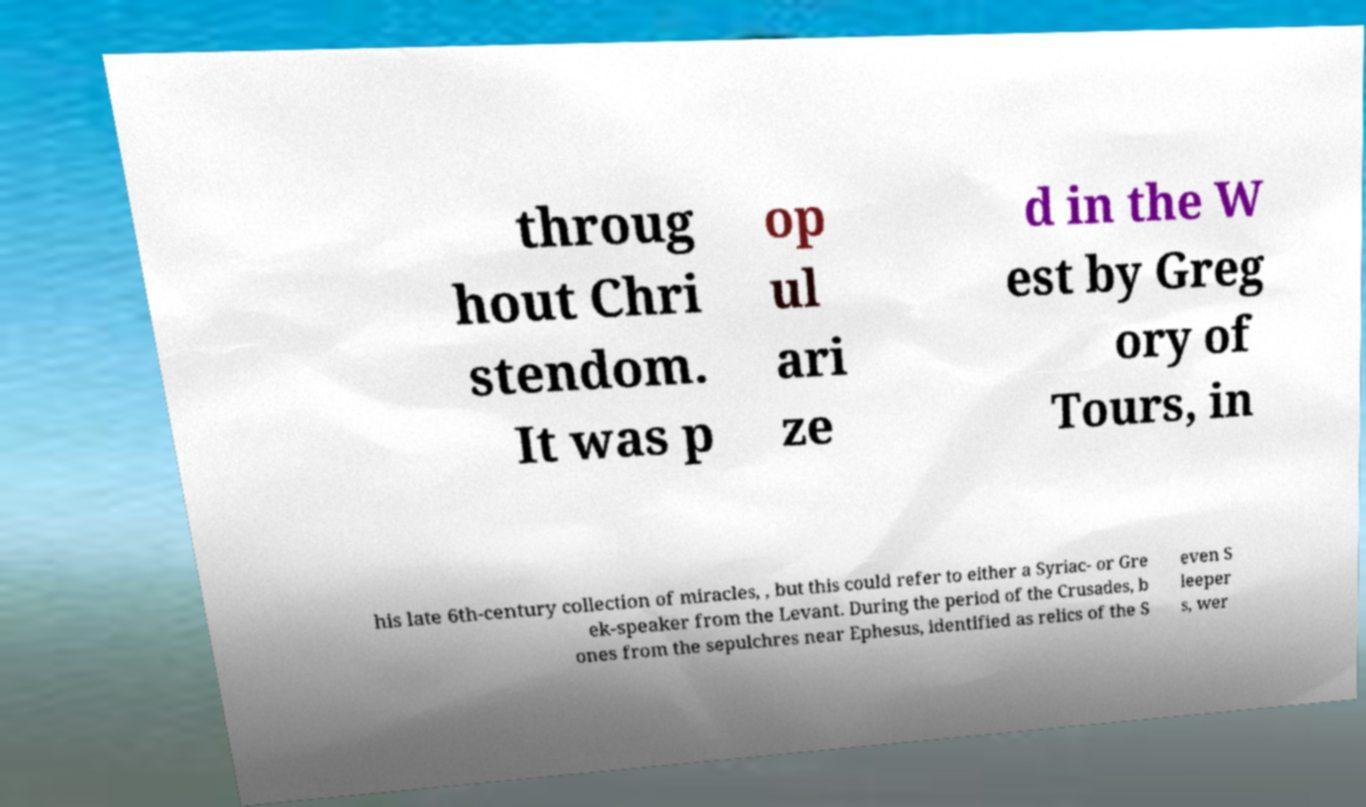I need the written content from this picture converted into text. Can you do that? throug hout Chri stendom. It was p op ul ari ze d in the W est by Greg ory of Tours, in his late 6th-century collection of miracles, , but this could refer to either a Syriac- or Gre ek-speaker from the Levant. During the period of the Crusades, b ones from the sepulchres near Ephesus, identified as relics of the S even S leeper s, wer 